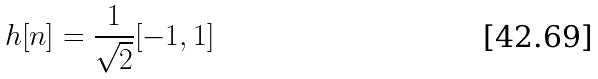Convert formula to latex. <formula><loc_0><loc_0><loc_500><loc_500>h [ n ] = \frac { 1 } { \sqrt { 2 } } [ - 1 , 1 ]</formula> 